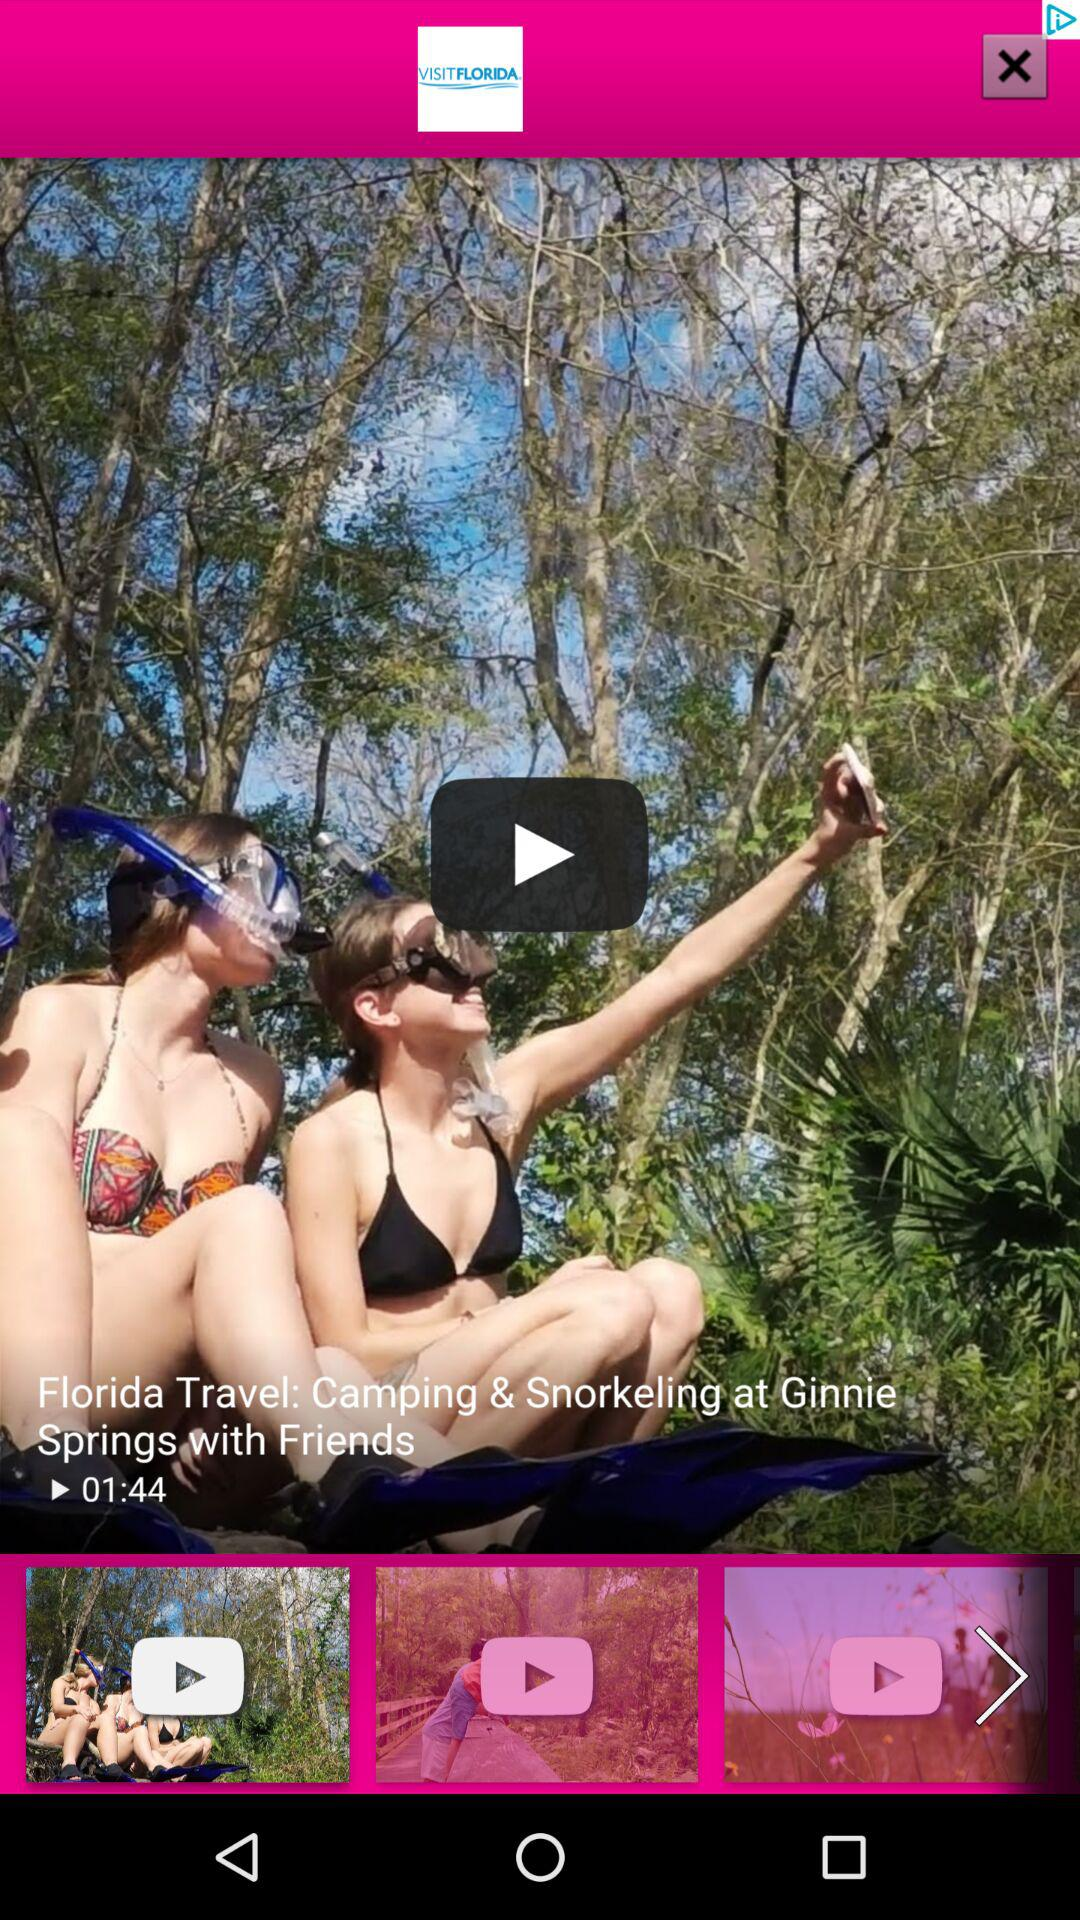What is the duration of the video? The duration is 1 minute and 44 seconds. 